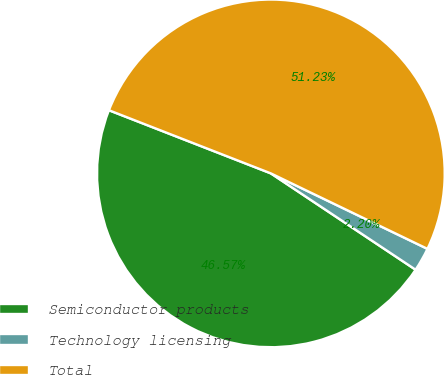Convert chart to OTSL. <chart><loc_0><loc_0><loc_500><loc_500><pie_chart><fcel>Semiconductor products<fcel>Technology licensing<fcel>Total<nl><fcel>46.57%<fcel>2.2%<fcel>51.23%<nl></chart> 